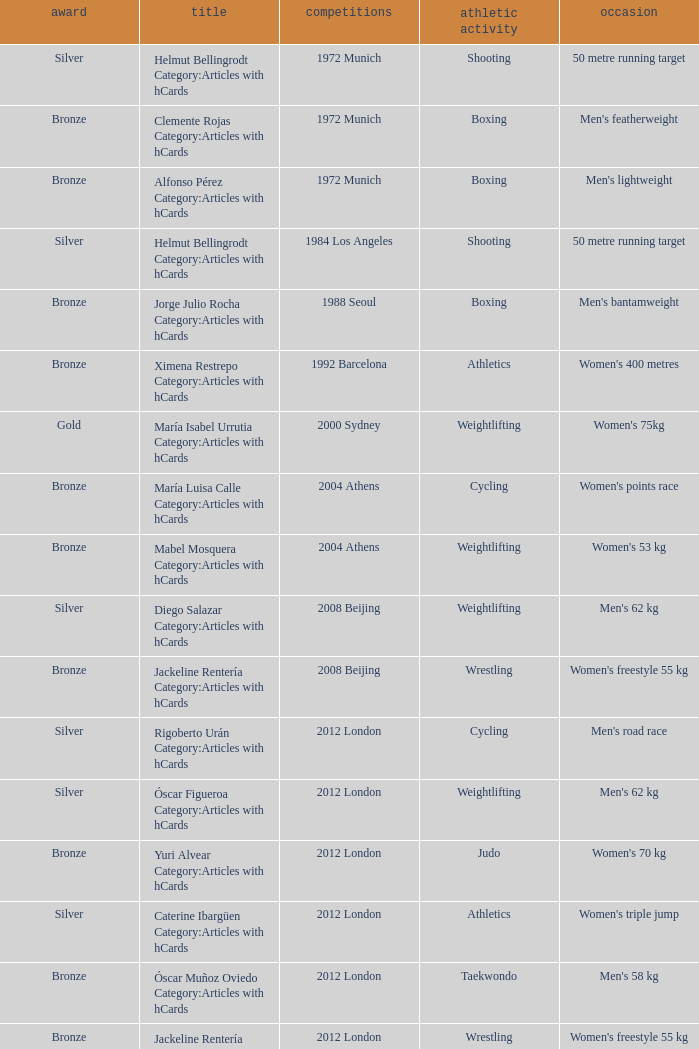What wrestling event was participated in during the 2008 Beijing games? Women's freestyle 55 kg. 